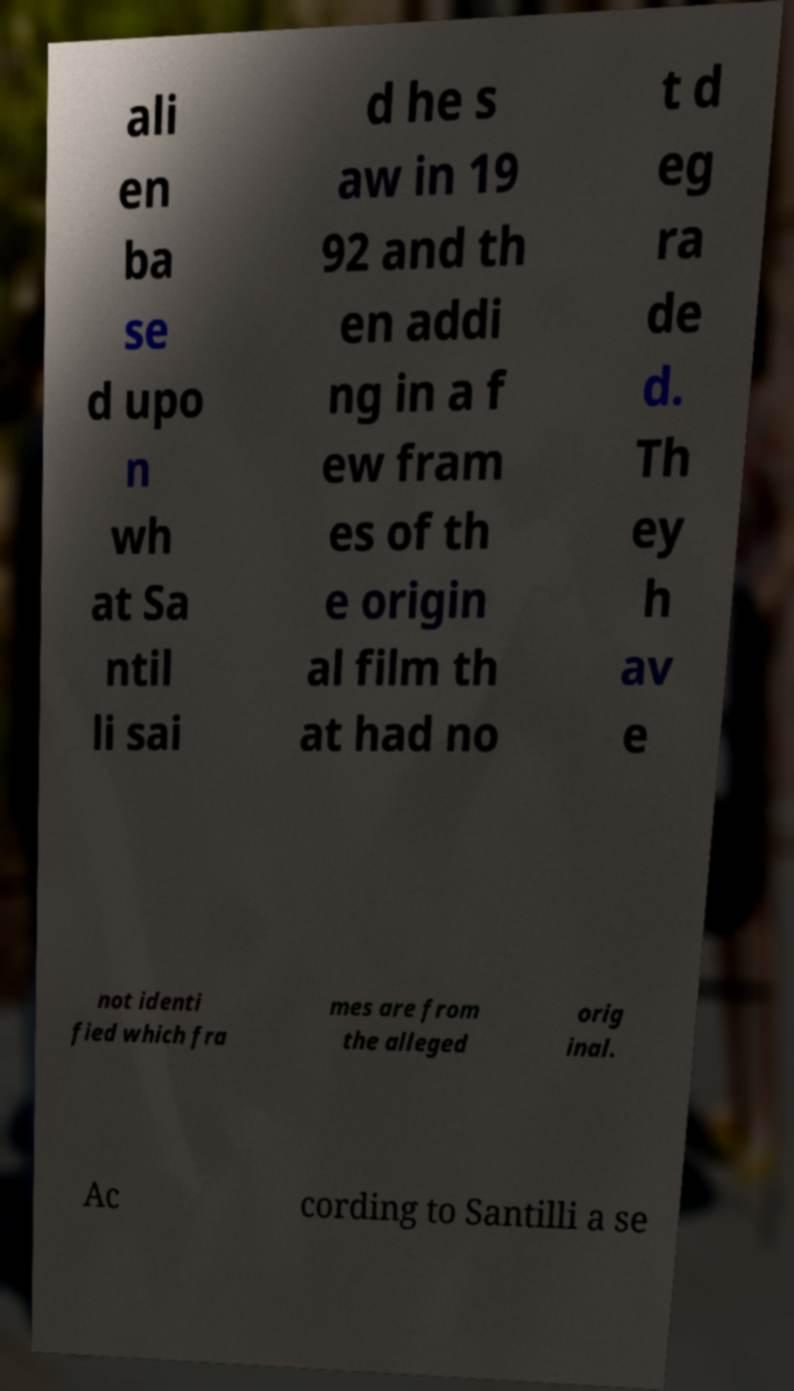Can you accurately transcribe the text from the provided image for me? ali en ba se d upo n wh at Sa ntil li sai d he s aw in 19 92 and th en addi ng in a f ew fram es of th e origin al film th at had no t d eg ra de d. Th ey h av e not identi fied which fra mes are from the alleged orig inal. Ac cording to Santilli a se 